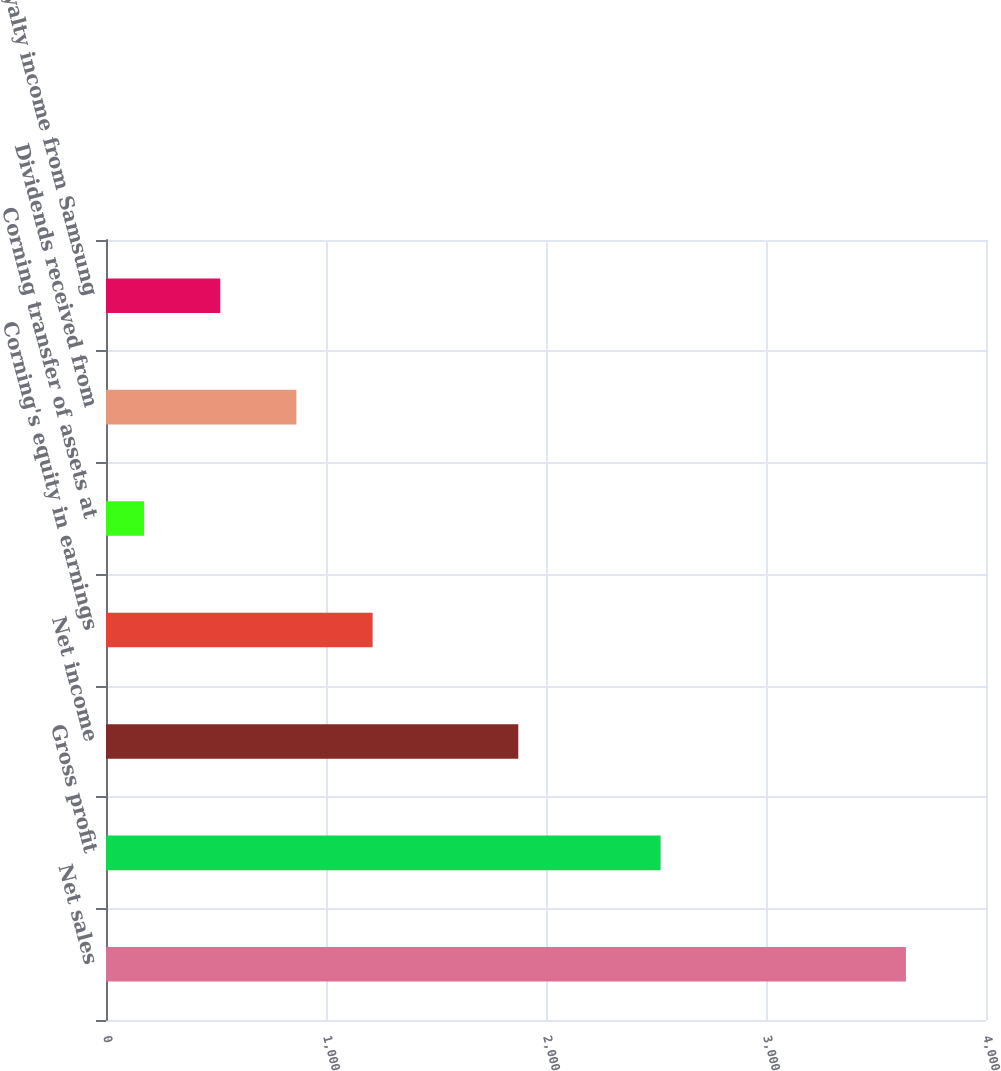Convert chart to OTSL. <chart><loc_0><loc_0><loc_500><loc_500><bar_chart><fcel>Net sales<fcel>Gross profit<fcel>Net income<fcel>Corning's equity in earnings<fcel>Corning transfer of assets at<fcel>Dividends received from<fcel>Royalty income from Samsung<nl><fcel>3636<fcel>2521<fcel>1874<fcel>1211.9<fcel>173<fcel>865.6<fcel>519.3<nl></chart> 